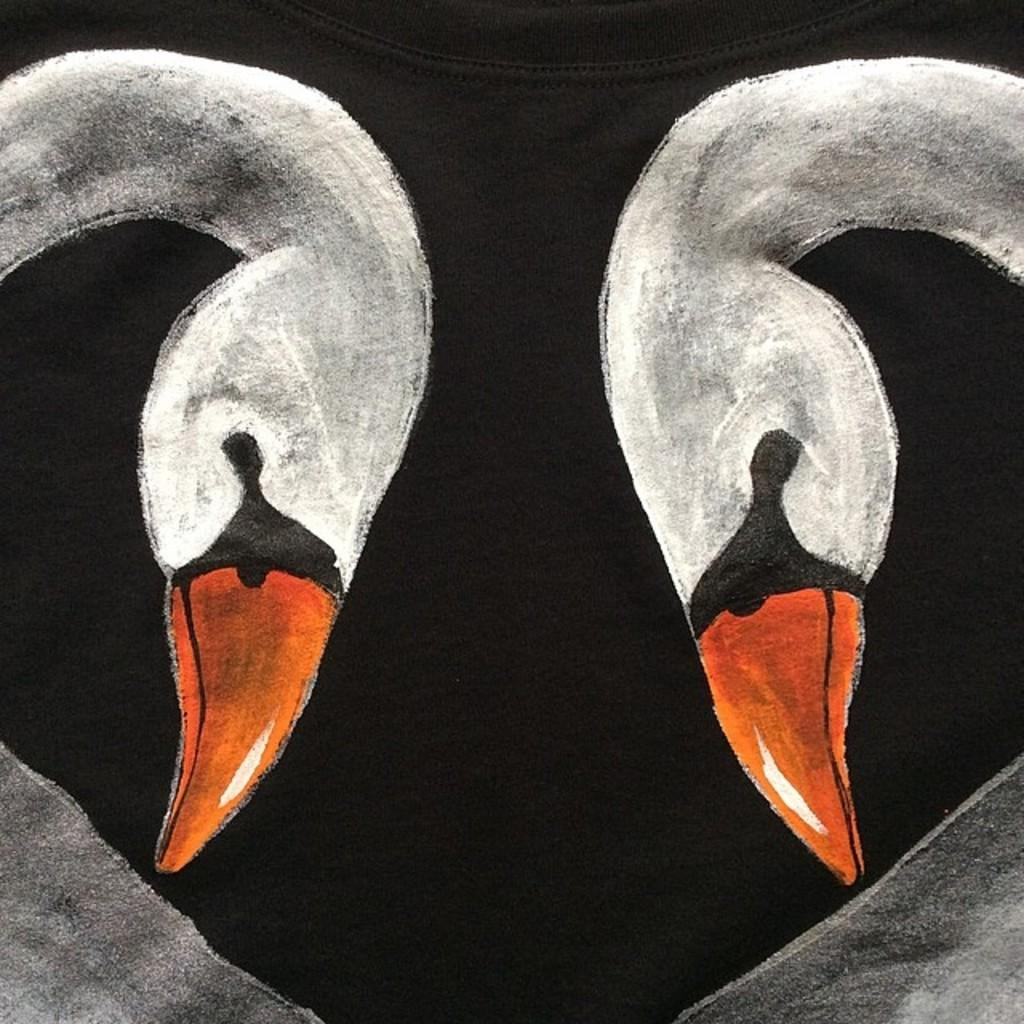What is the main subject of the image? There is art in the image. What is the art placed on? The art is on a black-colored cloth. What type of animal can be seen playing with a hammer on the seashore in the image? There is no animal, hammer, or seashore present in the image; it only features art on a black-colored cloth. 